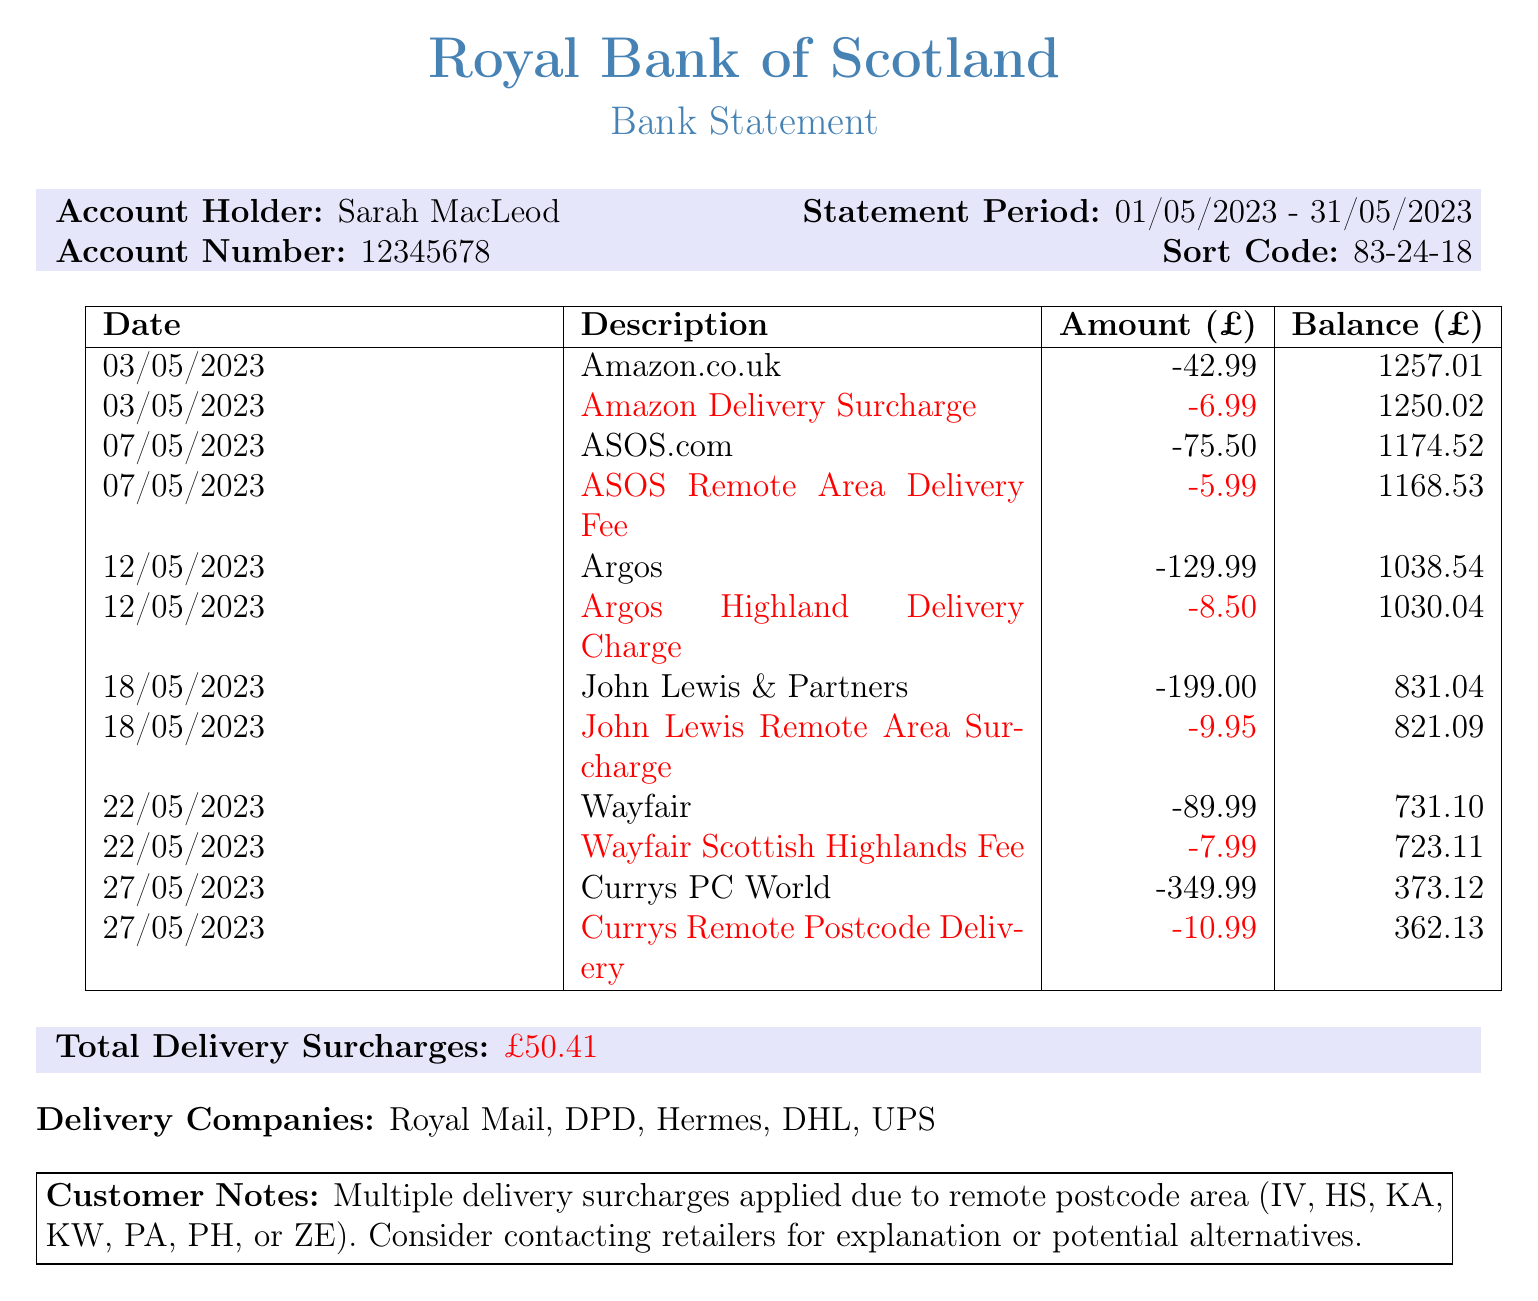What is the account holder's name? The account holder's name is listed at the top of the document.
Answer: Sarah MacLeod What is the statement period? The statement period is specified in the document showing the dates covered by this statement.
Answer: 01/05/2023 - 31/05/2023 What is the total amount of delivery surcharges? The total delivery surcharges are consolidated in a specific section of the document.
Answer: £50.41 Which retailer charged the highest amount in a single transaction? To find this, I look at the transaction amounts listed; the highest amount is from the transaction descriptions.
Answer: Currys PC World What date was the Amazon delivery surcharge applied? The specific date of the transaction related to Amazon is needed, which is written in the transaction list.
Answer: 03/05/2023 Which company has a remote area surcharge listed? This involves checking the transaction descriptions for surcharges related to remote areas.
Answer: John Lewis How much was the delivery fee from Wayfair? The amount for the specific transaction with Wayfair related to the fee is mentioned in the transactions.
Answer: -7.99 What is the bank name shown in the document? The bank name is prominently displayed at the top of the document as the issuing institution.
Answer: Royal Bank of Scotland What is suggested in the customer notes? The customer notes section contains recommendations or observations pertaining to the surcharges.
Answer: Consider contacting retailers for explanation or potential alternatives 